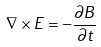Convert formula to latex. <formula><loc_0><loc_0><loc_500><loc_500>\nabla \times E = - \frac { \partial B } { \partial t }</formula> 